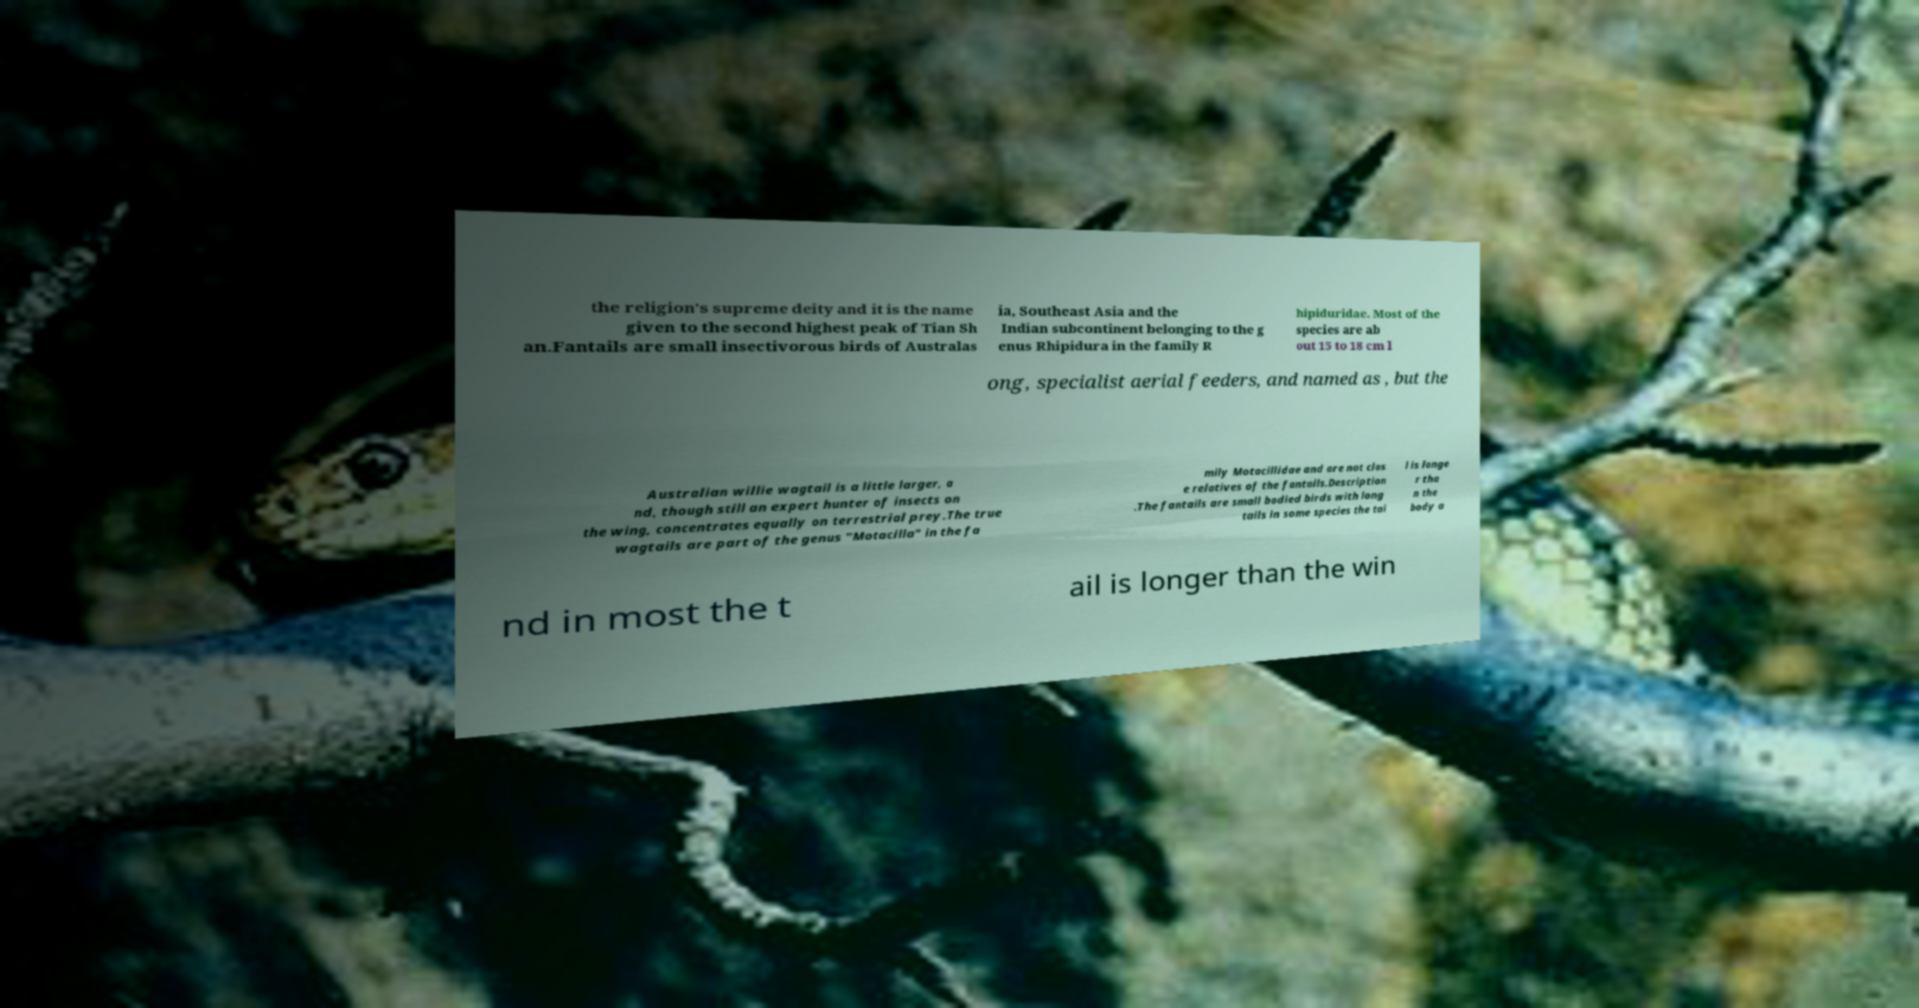Can you read and provide the text displayed in the image?This photo seems to have some interesting text. Can you extract and type it out for me? the religion's supreme deity and it is the name given to the second highest peak of Tian Sh an.Fantails are small insectivorous birds of Australas ia, Southeast Asia and the Indian subcontinent belonging to the g enus Rhipidura in the family R hipiduridae. Most of the species are ab out 15 to 18 cm l ong, specialist aerial feeders, and named as , but the Australian willie wagtail is a little larger, a nd, though still an expert hunter of insects on the wing, concentrates equally on terrestrial prey.The true wagtails are part of the genus "Motacilla" in the fa mily Motacillidae and are not clos e relatives of the fantails.Description .The fantails are small bodied birds with long tails in some species the tai l is longe r tha n the body a nd in most the t ail is longer than the win 